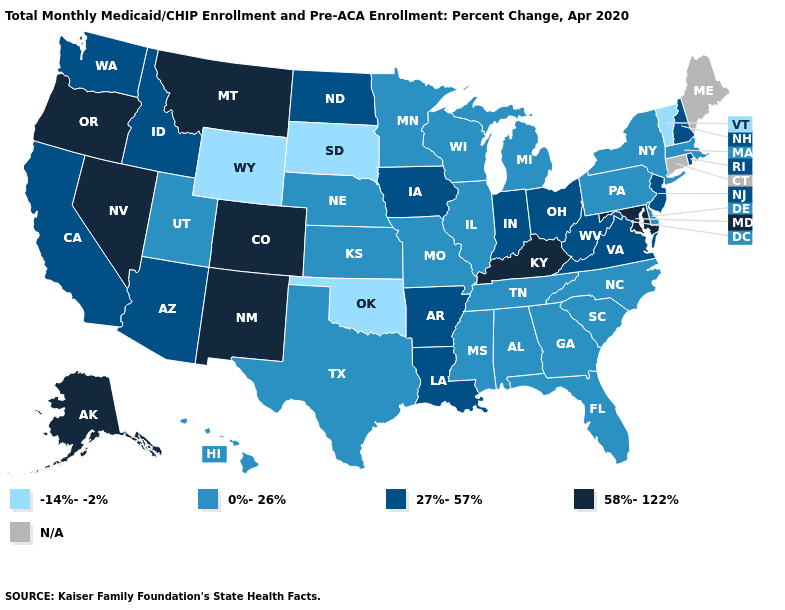Does the map have missing data?
Give a very brief answer. Yes. What is the value of South Dakota?
Keep it brief. -14%--2%. Name the states that have a value in the range 58%-122%?
Short answer required. Alaska, Colorado, Kentucky, Maryland, Montana, Nevada, New Mexico, Oregon. What is the lowest value in the West?
Write a very short answer. -14%--2%. What is the highest value in states that border Massachusetts?
Quick response, please. 27%-57%. Name the states that have a value in the range 27%-57%?
Short answer required. Arizona, Arkansas, California, Idaho, Indiana, Iowa, Louisiana, New Hampshire, New Jersey, North Dakota, Ohio, Rhode Island, Virginia, Washington, West Virginia. How many symbols are there in the legend?
Concise answer only. 5. Among the states that border Arkansas , does Missouri have the highest value?
Be succinct. No. Does Vermont have the lowest value in the USA?
Concise answer only. Yes. Name the states that have a value in the range 27%-57%?
Write a very short answer. Arizona, Arkansas, California, Idaho, Indiana, Iowa, Louisiana, New Hampshire, New Jersey, North Dakota, Ohio, Rhode Island, Virginia, Washington, West Virginia. What is the value of Louisiana?
Give a very brief answer. 27%-57%. Does Kentucky have the highest value in the USA?
Keep it brief. Yes. 